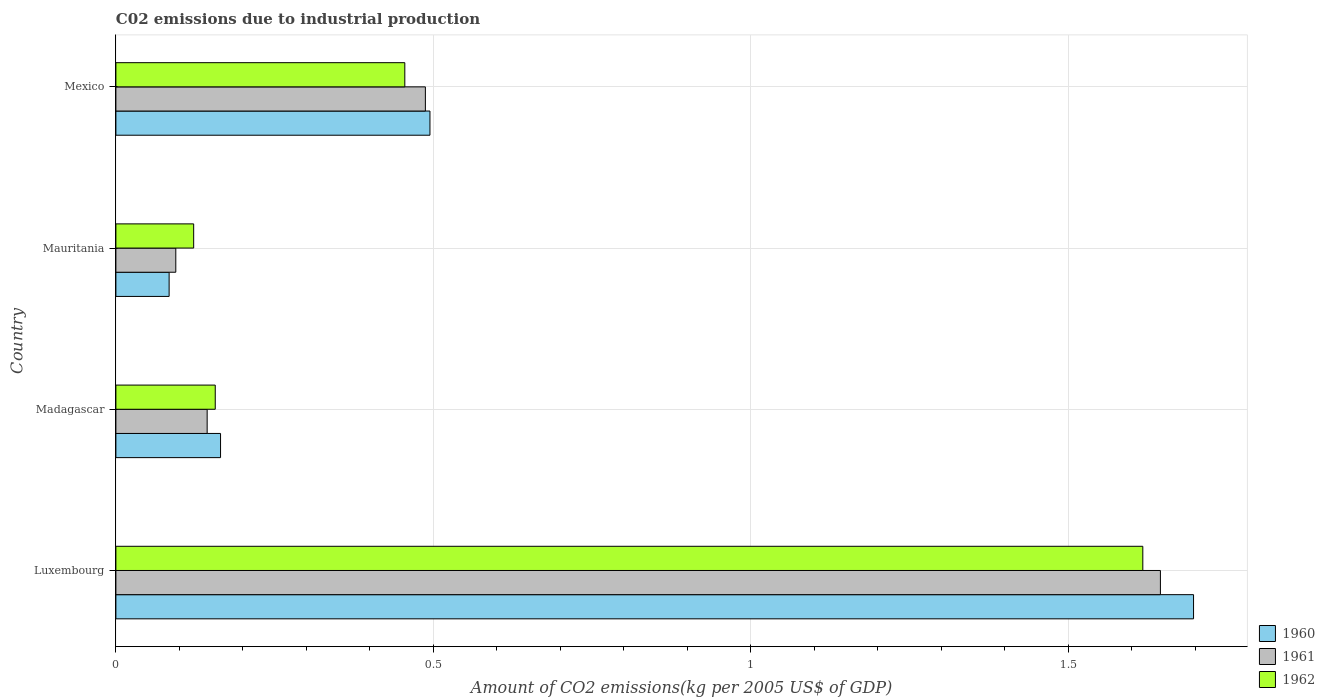How many different coloured bars are there?
Keep it short and to the point. 3. Are the number of bars per tick equal to the number of legend labels?
Give a very brief answer. Yes. Are the number of bars on each tick of the Y-axis equal?
Provide a short and direct response. Yes. How many bars are there on the 4th tick from the top?
Provide a succinct answer. 3. How many bars are there on the 4th tick from the bottom?
Offer a very short reply. 3. What is the label of the 2nd group of bars from the top?
Offer a terse response. Mauritania. In how many cases, is the number of bars for a given country not equal to the number of legend labels?
Your answer should be compact. 0. What is the amount of CO2 emitted due to industrial production in 1962 in Madagascar?
Ensure brevity in your answer.  0.16. Across all countries, what is the maximum amount of CO2 emitted due to industrial production in 1962?
Keep it short and to the point. 1.62. Across all countries, what is the minimum amount of CO2 emitted due to industrial production in 1960?
Offer a terse response. 0.08. In which country was the amount of CO2 emitted due to industrial production in 1962 maximum?
Provide a succinct answer. Luxembourg. In which country was the amount of CO2 emitted due to industrial production in 1960 minimum?
Provide a succinct answer. Mauritania. What is the total amount of CO2 emitted due to industrial production in 1961 in the graph?
Give a very brief answer. 2.37. What is the difference between the amount of CO2 emitted due to industrial production in 1960 in Madagascar and that in Mauritania?
Your response must be concise. 0.08. What is the difference between the amount of CO2 emitted due to industrial production in 1961 in Madagascar and the amount of CO2 emitted due to industrial production in 1962 in Mexico?
Your answer should be very brief. -0.31. What is the average amount of CO2 emitted due to industrial production in 1960 per country?
Provide a succinct answer. 0.61. What is the difference between the amount of CO2 emitted due to industrial production in 1960 and amount of CO2 emitted due to industrial production in 1962 in Mauritania?
Give a very brief answer. -0.04. What is the ratio of the amount of CO2 emitted due to industrial production in 1962 in Madagascar to that in Mexico?
Offer a terse response. 0.34. Is the difference between the amount of CO2 emitted due to industrial production in 1960 in Mauritania and Mexico greater than the difference between the amount of CO2 emitted due to industrial production in 1962 in Mauritania and Mexico?
Your answer should be very brief. No. What is the difference between the highest and the second highest amount of CO2 emitted due to industrial production in 1962?
Make the answer very short. 1.16. What is the difference between the highest and the lowest amount of CO2 emitted due to industrial production in 1960?
Offer a terse response. 1.61. In how many countries, is the amount of CO2 emitted due to industrial production in 1961 greater than the average amount of CO2 emitted due to industrial production in 1961 taken over all countries?
Your response must be concise. 1. Is it the case that in every country, the sum of the amount of CO2 emitted due to industrial production in 1962 and amount of CO2 emitted due to industrial production in 1961 is greater than the amount of CO2 emitted due to industrial production in 1960?
Your response must be concise. Yes. What is the difference between two consecutive major ticks on the X-axis?
Your answer should be compact. 0.5. Are the values on the major ticks of X-axis written in scientific E-notation?
Keep it short and to the point. No. Does the graph contain any zero values?
Offer a very short reply. No. Does the graph contain grids?
Give a very brief answer. Yes. Where does the legend appear in the graph?
Provide a succinct answer. Bottom right. How many legend labels are there?
Offer a very short reply. 3. What is the title of the graph?
Your answer should be very brief. C02 emissions due to industrial production. What is the label or title of the X-axis?
Give a very brief answer. Amount of CO2 emissions(kg per 2005 US$ of GDP). What is the Amount of CO2 emissions(kg per 2005 US$ of GDP) in 1960 in Luxembourg?
Your answer should be very brief. 1.7. What is the Amount of CO2 emissions(kg per 2005 US$ of GDP) in 1961 in Luxembourg?
Offer a terse response. 1.65. What is the Amount of CO2 emissions(kg per 2005 US$ of GDP) of 1962 in Luxembourg?
Your answer should be compact. 1.62. What is the Amount of CO2 emissions(kg per 2005 US$ of GDP) in 1960 in Madagascar?
Provide a short and direct response. 0.16. What is the Amount of CO2 emissions(kg per 2005 US$ of GDP) of 1961 in Madagascar?
Ensure brevity in your answer.  0.14. What is the Amount of CO2 emissions(kg per 2005 US$ of GDP) of 1962 in Madagascar?
Give a very brief answer. 0.16. What is the Amount of CO2 emissions(kg per 2005 US$ of GDP) in 1960 in Mauritania?
Your response must be concise. 0.08. What is the Amount of CO2 emissions(kg per 2005 US$ of GDP) in 1961 in Mauritania?
Provide a succinct answer. 0.09. What is the Amount of CO2 emissions(kg per 2005 US$ of GDP) of 1962 in Mauritania?
Your answer should be very brief. 0.12. What is the Amount of CO2 emissions(kg per 2005 US$ of GDP) of 1960 in Mexico?
Your answer should be compact. 0.49. What is the Amount of CO2 emissions(kg per 2005 US$ of GDP) in 1961 in Mexico?
Offer a terse response. 0.49. What is the Amount of CO2 emissions(kg per 2005 US$ of GDP) in 1962 in Mexico?
Ensure brevity in your answer.  0.46. Across all countries, what is the maximum Amount of CO2 emissions(kg per 2005 US$ of GDP) of 1960?
Offer a terse response. 1.7. Across all countries, what is the maximum Amount of CO2 emissions(kg per 2005 US$ of GDP) in 1961?
Offer a very short reply. 1.65. Across all countries, what is the maximum Amount of CO2 emissions(kg per 2005 US$ of GDP) in 1962?
Provide a short and direct response. 1.62. Across all countries, what is the minimum Amount of CO2 emissions(kg per 2005 US$ of GDP) of 1960?
Provide a succinct answer. 0.08. Across all countries, what is the minimum Amount of CO2 emissions(kg per 2005 US$ of GDP) of 1961?
Your answer should be compact. 0.09. Across all countries, what is the minimum Amount of CO2 emissions(kg per 2005 US$ of GDP) in 1962?
Offer a very short reply. 0.12. What is the total Amount of CO2 emissions(kg per 2005 US$ of GDP) in 1960 in the graph?
Your answer should be very brief. 2.44. What is the total Amount of CO2 emissions(kg per 2005 US$ of GDP) in 1961 in the graph?
Provide a succinct answer. 2.37. What is the total Amount of CO2 emissions(kg per 2005 US$ of GDP) of 1962 in the graph?
Offer a very short reply. 2.35. What is the difference between the Amount of CO2 emissions(kg per 2005 US$ of GDP) in 1960 in Luxembourg and that in Madagascar?
Your response must be concise. 1.53. What is the difference between the Amount of CO2 emissions(kg per 2005 US$ of GDP) in 1961 in Luxembourg and that in Madagascar?
Your answer should be compact. 1.5. What is the difference between the Amount of CO2 emissions(kg per 2005 US$ of GDP) of 1962 in Luxembourg and that in Madagascar?
Provide a short and direct response. 1.46. What is the difference between the Amount of CO2 emissions(kg per 2005 US$ of GDP) in 1960 in Luxembourg and that in Mauritania?
Your answer should be compact. 1.61. What is the difference between the Amount of CO2 emissions(kg per 2005 US$ of GDP) in 1961 in Luxembourg and that in Mauritania?
Ensure brevity in your answer.  1.55. What is the difference between the Amount of CO2 emissions(kg per 2005 US$ of GDP) of 1962 in Luxembourg and that in Mauritania?
Provide a short and direct response. 1.49. What is the difference between the Amount of CO2 emissions(kg per 2005 US$ of GDP) of 1960 in Luxembourg and that in Mexico?
Provide a short and direct response. 1.2. What is the difference between the Amount of CO2 emissions(kg per 2005 US$ of GDP) of 1961 in Luxembourg and that in Mexico?
Give a very brief answer. 1.16. What is the difference between the Amount of CO2 emissions(kg per 2005 US$ of GDP) in 1962 in Luxembourg and that in Mexico?
Make the answer very short. 1.16. What is the difference between the Amount of CO2 emissions(kg per 2005 US$ of GDP) of 1960 in Madagascar and that in Mauritania?
Ensure brevity in your answer.  0.08. What is the difference between the Amount of CO2 emissions(kg per 2005 US$ of GDP) of 1961 in Madagascar and that in Mauritania?
Your response must be concise. 0.05. What is the difference between the Amount of CO2 emissions(kg per 2005 US$ of GDP) of 1962 in Madagascar and that in Mauritania?
Make the answer very short. 0.03. What is the difference between the Amount of CO2 emissions(kg per 2005 US$ of GDP) in 1960 in Madagascar and that in Mexico?
Your answer should be compact. -0.33. What is the difference between the Amount of CO2 emissions(kg per 2005 US$ of GDP) in 1961 in Madagascar and that in Mexico?
Provide a short and direct response. -0.34. What is the difference between the Amount of CO2 emissions(kg per 2005 US$ of GDP) of 1962 in Madagascar and that in Mexico?
Give a very brief answer. -0.3. What is the difference between the Amount of CO2 emissions(kg per 2005 US$ of GDP) in 1960 in Mauritania and that in Mexico?
Provide a succinct answer. -0.41. What is the difference between the Amount of CO2 emissions(kg per 2005 US$ of GDP) in 1961 in Mauritania and that in Mexico?
Provide a short and direct response. -0.39. What is the difference between the Amount of CO2 emissions(kg per 2005 US$ of GDP) of 1962 in Mauritania and that in Mexico?
Your response must be concise. -0.33. What is the difference between the Amount of CO2 emissions(kg per 2005 US$ of GDP) in 1960 in Luxembourg and the Amount of CO2 emissions(kg per 2005 US$ of GDP) in 1961 in Madagascar?
Give a very brief answer. 1.55. What is the difference between the Amount of CO2 emissions(kg per 2005 US$ of GDP) of 1960 in Luxembourg and the Amount of CO2 emissions(kg per 2005 US$ of GDP) of 1962 in Madagascar?
Your answer should be compact. 1.54. What is the difference between the Amount of CO2 emissions(kg per 2005 US$ of GDP) in 1961 in Luxembourg and the Amount of CO2 emissions(kg per 2005 US$ of GDP) in 1962 in Madagascar?
Ensure brevity in your answer.  1.49. What is the difference between the Amount of CO2 emissions(kg per 2005 US$ of GDP) in 1960 in Luxembourg and the Amount of CO2 emissions(kg per 2005 US$ of GDP) in 1961 in Mauritania?
Your answer should be very brief. 1.6. What is the difference between the Amount of CO2 emissions(kg per 2005 US$ of GDP) of 1960 in Luxembourg and the Amount of CO2 emissions(kg per 2005 US$ of GDP) of 1962 in Mauritania?
Your response must be concise. 1.57. What is the difference between the Amount of CO2 emissions(kg per 2005 US$ of GDP) of 1961 in Luxembourg and the Amount of CO2 emissions(kg per 2005 US$ of GDP) of 1962 in Mauritania?
Provide a short and direct response. 1.52. What is the difference between the Amount of CO2 emissions(kg per 2005 US$ of GDP) of 1960 in Luxembourg and the Amount of CO2 emissions(kg per 2005 US$ of GDP) of 1961 in Mexico?
Keep it short and to the point. 1.21. What is the difference between the Amount of CO2 emissions(kg per 2005 US$ of GDP) in 1960 in Luxembourg and the Amount of CO2 emissions(kg per 2005 US$ of GDP) in 1962 in Mexico?
Keep it short and to the point. 1.24. What is the difference between the Amount of CO2 emissions(kg per 2005 US$ of GDP) of 1961 in Luxembourg and the Amount of CO2 emissions(kg per 2005 US$ of GDP) of 1962 in Mexico?
Provide a short and direct response. 1.19. What is the difference between the Amount of CO2 emissions(kg per 2005 US$ of GDP) of 1960 in Madagascar and the Amount of CO2 emissions(kg per 2005 US$ of GDP) of 1961 in Mauritania?
Your response must be concise. 0.07. What is the difference between the Amount of CO2 emissions(kg per 2005 US$ of GDP) in 1960 in Madagascar and the Amount of CO2 emissions(kg per 2005 US$ of GDP) in 1962 in Mauritania?
Provide a succinct answer. 0.04. What is the difference between the Amount of CO2 emissions(kg per 2005 US$ of GDP) in 1961 in Madagascar and the Amount of CO2 emissions(kg per 2005 US$ of GDP) in 1962 in Mauritania?
Keep it short and to the point. 0.02. What is the difference between the Amount of CO2 emissions(kg per 2005 US$ of GDP) of 1960 in Madagascar and the Amount of CO2 emissions(kg per 2005 US$ of GDP) of 1961 in Mexico?
Ensure brevity in your answer.  -0.32. What is the difference between the Amount of CO2 emissions(kg per 2005 US$ of GDP) of 1960 in Madagascar and the Amount of CO2 emissions(kg per 2005 US$ of GDP) of 1962 in Mexico?
Make the answer very short. -0.29. What is the difference between the Amount of CO2 emissions(kg per 2005 US$ of GDP) in 1961 in Madagascar and the Amount of CO2 emissions(kg per 2005 US$ of GDP) in 1962 in Mexico?
Your answer should be compact. -0.31. What is the difference between the Amount of CO2 emissions(kg per 2005 US$ of GDP) of 1960 in Mauritania and the Amount of CO2 emissions(kg per 2005 US$ of GDP) of 1961 in Mexico?
Make the answer very short. -0.4. What is the difference between the Amount of CO2 emissions(kg per 2005 US$ of GDP) in 1960 in Mauritania and the Amount of CO2 emissions(kg per 2005 US$ of GDP) in 1962 in Mexico?
Ensure brevity in your answer.  -0.37. What is the difference between the Amount of CO2 emissions(kg per 2005 US$ of GDP) of 1961 in Mauritania and the Amount of CO2 emissions(kg per 2005 US$ of GDP) of 1962 in Mexico?
Your answer should be very brief. -0.36. What is the average Amount of CO2 emissions(kg per 2005 US$ of GDP) in 1960 per country?
Offer a very short reply. 0.61. What is the average Amount of CO2 emissions(kg per 2005 US$ of GDP) in 1961 per country?
Offer a very short reply. 0.59. What is the average Amount of CO2 emissions(kg per 2005 US$ of GDP) of 1962 per country?
Your response must be concise. 0.59. What is the difference between the Amount of CO2 emissions(kg per 2005 US$ of GDP) of 1960 and Amount of CO2 emissions(kg per 2005 US$ of GDP) of 1961 in Luxembourg?
Your response must be concise. 0.05. What is the difference between the Amount of CO2 emissions(kg per 2005 US$ of GDP) of 1960 and Amount of CO2 emissions(kg per 2005 US$ of GDP) of 1962 in Luxembourg?
Offer a terse response. 0.08. What is the difference between the Amount of CO2 emissions(kg per 2005 US$ of GDP) of 1961 and Amount of CO2 emissions(kg per 2005 US$ of GDP) of 1962 in Luxembourg?
Offer a very short reply. 0.03. What is the difference between the Amount of CO2 emissions(kg per 2005 US$ of GDP) in 1960 and Amount of CO2 emissions(kg per 2005 US$ of GDP) in 1961 in Madagascar?
Provide a succinct answer. 0.02. What is the difference between the Amount of CO2 emissions(kg per 2005 US$ of GDP) in 1960 and Amount of CO2 emissions(kg per 2005 US$ of GDP) in 1962 in Madagascar?
Give a very brief answer. 0.01. What is the difference between the Amount of CO2 emissions(kg per 2005 US$ of GDP) in 1961 and Amount of CO2 emissions(kg per 2005 US$ of GDP) in 1962 in Madagascar?
Provide a short and direct response. -0.01. What is the difference between the Amount of CO2 emissions(kg per 2005 US$ of GDP) in 1960 and Amount of CO2 emissions(kg per 2005 US$ of GDP) in 1961 in Mauritania?
Your answer should be compact. -0.01. What is the difference between the Amount of CO2 emissions(kg per 2005 US$ of GDP) of 1960 and Amount of CO2 emissions(kg per 2005 US$ of GDP) of 1962 in Mauritania?
Give a very brief answer. -0.04. What is the difference between the Amount of CO2 emissions(kg per 2005 US$ of GDP) in 1961 and Amount of CO2 emissions(kg per 2005 US$ of GDP) in 1962 in Mauritania?
Give a very brief answer. -0.03. What is the difference between the Amount of CO2 emissions(kg per 2005 US$ of GDP) of 1960 and Amount of CO2 emissions(kg per 2005 US$ of GDP) of 1961 in Mexico?
Your answer should be very brief. 0.01. What is the difference between the Amount of CO2 emissions(kg per 2005 US$ of GDP) of 1960 and Amount of CO2 emissions(kg per 2005 US$ of GDP) of 1962 in Mexico?
Your answer should be compact. 0.04. What is the difference between the Amount of CO2 emissions(kg per 2005 US$ of GDP) of 1961 and Amount of CO2 emissions(kg per 2005 US$ of GDP) of 1962 in Mexico?
Offer a terse response. 0.03. What is the ratio of the Amount of CO2 emissions(kg per 2005 US$ of GDP) of 1960 in Luxembourg to that in Madagascar?
Provide a short and direct response. 10.3. What is the ratio of the Amount of CO2 emissions(kg per 2005 US$ of GDP) in 1961 in Luxembourg to that in Madagascar?
Provide a short and direct response. 11.44. What is the ratio of the Amount of CO2 emissions(kg per 2005 US$ of GDP) in 1962 in Luxembourg to that in Madagascar?
Your answer should be compact. 10.34. What is the ratio of the Amount of CO2 emissions(kg per 2005 US$ of GDP) in 1960 in Luxembourg to that in Mauritania?
Your answer should be compact. 20.24. What is the ratio of the Amount of CO2 emissions(kg per 2005 US$ of GDP) of 1961 in Luxembourg to that in Mauritania?
Make the answer very short. 17.44. What is the ratio of the Amount of CO2 emissions(kg per 2005 US$ of GDP) in 1962 in Luxembourg to that in Mauritania?
Give a very brief answer. 13.2. What is the ratio of the Amount of CO2 emissions(kg per 2005 US$ of GDP) in 1960 in Luxembourg to that in Mexico?
Give a very brief answer. 3.43. What is the ratio of the Amount of CO2 emissions(kg per 2005 US$ of GDP) of 1961 in Luxembourg to that in Mexico?
Give a very brief answer. 3.38. What is the ratio of the Amount of CO2 emissions(kg per 2005 US$ of GDP) in 1962 in Luxembourg to that in Mexico?
Provide a short and direct response. 3.55. What is the ratio of the Amount of CO2 emissions(kg per 2005 US$ of GDP) in 1960 in Madagascar to that in Mauritania?
Provide a succinct answer. 1.97. What is the ratio of the Amount of CO2 emissions(kg per 2005 US$ of GDP) in 1961 in Madagascar to that in Mauritania?
Your answer should be compact. 1.52. What is the ratio of the Amount of CO2 emissions(kg per 2005 US$ of GDP) of 1962 in Madagascar to that in Mauritania?
Your answer should be compact. 1.28. What is the ratio of the Amount of CO2 emissions(kg per 2005 US$ of GDP) of 1960 in Madagascar to that in Mexico?
Provide a succinct answer. 0.33. What is the ratio of the Amount of CO2 emissions(kg per 2005 US$ of GDP) in 1961 in Madagascar to that in Mexico?
Provide a succinct answer. 0.29. What is the ratio of the Amount of CO2 emissions(kg per 2005 US$ of GDP) of 1962 in Madagascar to that in Mexico?
Ensure brevity in your answer.  0.34. What is the ratio of the Amount of CO2 emissions(kg per 2005 US$ of GDP) in 1960 in Mauritania to that in Mexico?
Give a very brief answer. 0.17. What is the ratio of the Amount of CO2 emissions(kg per 2005 US$ of GDP) of 1961 in Mauritania to that in Mexico?
Ensure brevity in your answer.  0.19. What is the ratio of the Amount of CO2 emissions(kg per 2005 US$ of GDP) in 1962 in Mauritania to that in Mexico?
Offer a terse response. 0.27. What is the difference between the highest and the second highest Amount of CO2 emissions(kg per 2005 US$ of GDP) in 1960?
Offer a terse response. 1.2. What is the difference between the highest and the second highest Amount of CO2 emissions(kg per 2005 US$ of GDP) of 1961?
Your answer should be very brief. 1.16. What is the difference between the highest and the second highest Amount of CO2 emissions(kg per 2005 US$ of GDP) in 1962?
Ensure brevity in your answer.  1.16. What is the difference between the highest and the lowest Amount of CO2 emissions(kg per 2005 US$ of GDP) in 1960?
Your response must be concise. 1.61. What is the difference between the highest and the lowest Amount of CO2 emissions(kg per 2005 US$ of GDP) of 1961?
Keep it short and to the point. 1.55. What is the difference between the highest and the lowest Amount of CO2 emissions(kg per 2005 US$ of GDP) of 1962?
Offer a very short reply. 1.49. 